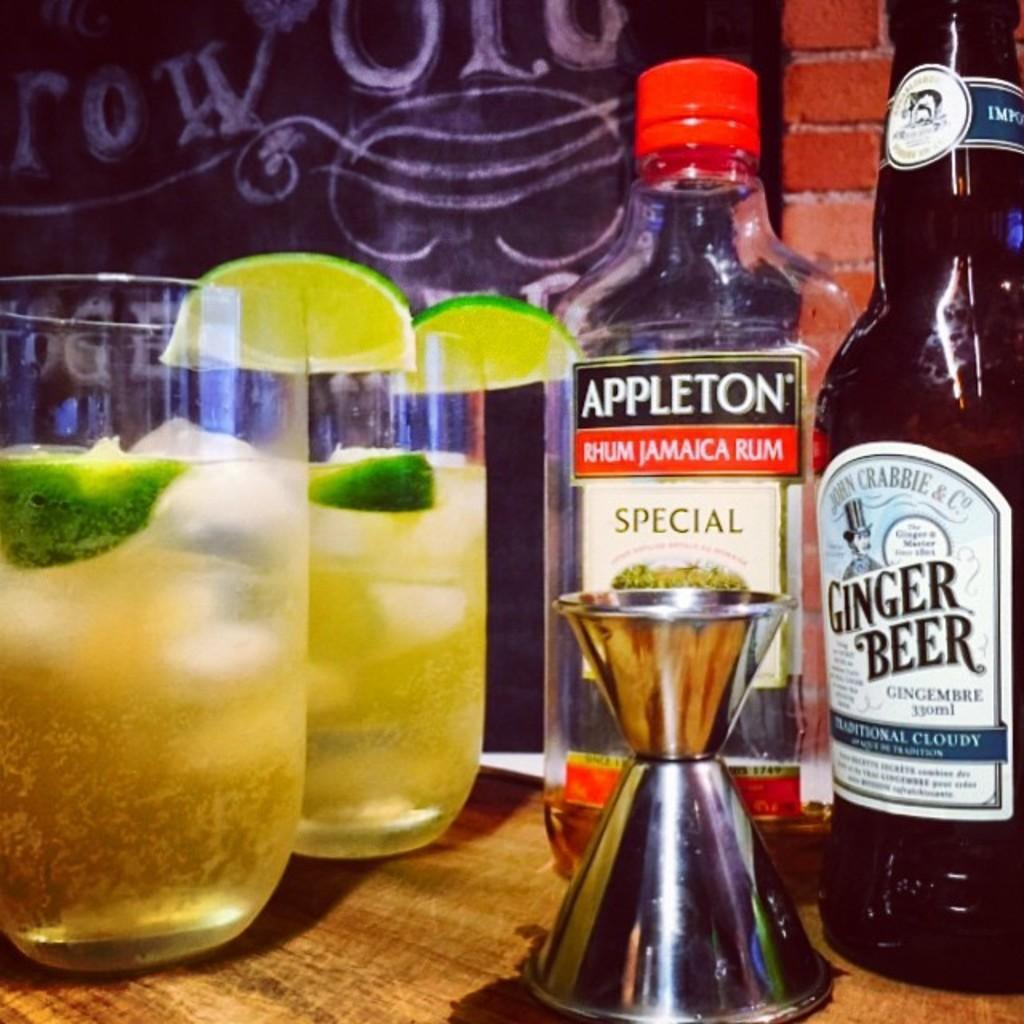Can you describe this image briefly? On this table there are glasses and bottles. In these glasses there are lemons. 